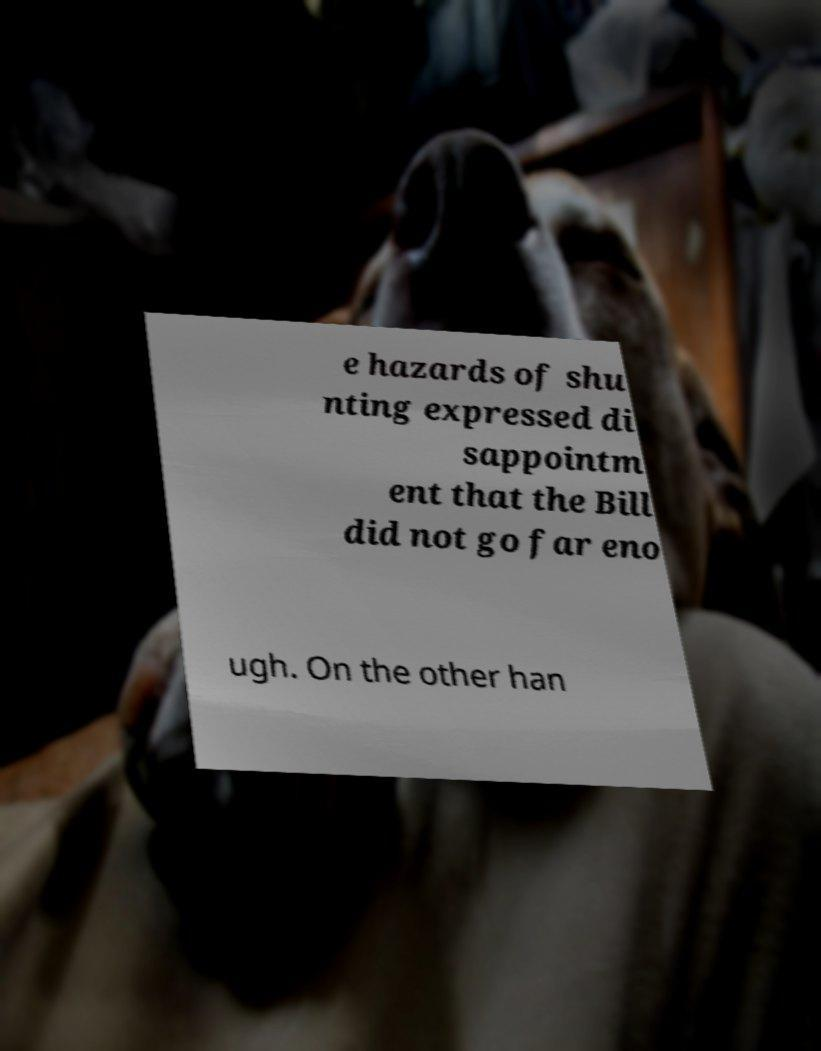What messages or text are displayed in this image? I need them in a readable, typed format. e hazards of shu nting expressed di sappointm ent that the Bill did not go far eno ugh. On the other han 